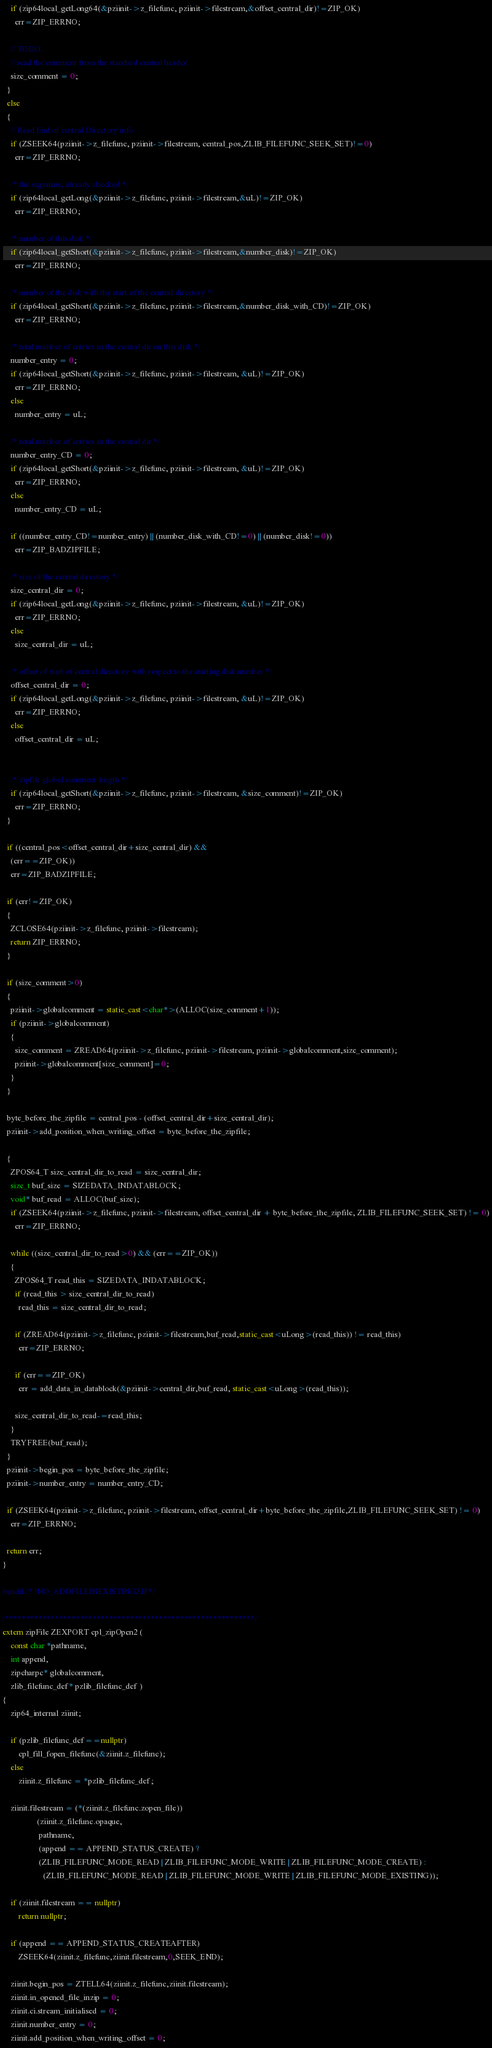Convert code to text. <code><loc_0><loc_0><loc_500><loc_500><_C++_>    if (zip64local_getLong64(&pziinit->z_filefunc, pziinit->filestream,&offset_central_dir)!=ZIP_OK)
      err=ZIP_ERRNO;

    // TODO..
    // read the comment from the standard central header.
    size_comment = 0;
  }
  else
  {
    // Read End of central Directory info
    if (ZSEEK64(pziinit->z_filefunc, pziinit->filestream, central_pos,ZLIB_FILEFUNC_SEEK_SET)!=0)
      err=ZIP_ERRNO;

    /* the signature, already checked */
    if (zip64local_getLong(&pziinit->z_filefunc, pziinit->filestream,&uL)!=ZIP_OK)
      err=ZIP_ERRNO;

    /* number of this disk */
    if (zip64local_getShort(&pziinit->z_filefunc, pziinit->filestream,&number_disk)!=ZIP_OK)
      err=ZIP_ERRNO;

    /* number of the disk with the start of the central directory */
    if (zip64local_getShort(&pziinit->z_filefunc, pziinit->filestream,&number_disk_with_CD)!=ZIP_OK)
      err=ZIP_ERRNO;

    /* total number of entries in the central dir on this disk */
    number_entry = 0;
    if (zip64local_getShort(&pziinit->z_filefunc, pziinit->filestream, &uL)!=ZIP_OK)
      err=ZIP_ERRNO;
    else
      number_entry = uL;

    /* total number of entries in the central dir */
    number_entry_CD = 0;
    if (zip64local_getShort(&pziinit->z_filefunc, pziinit->filestream, &uL)!=ZIP_OK)
      err=ZIP_ERRNO;
    else
      number_entry_CD = uL;

    if ((number_entry_CD!=number_entry) || (number_disk_with_CD!=0) || (number_disk!=0))
      err=ZIP_BADZIPFILE;

    /* size of the central directory */
    size_central_dir = 0;
    if (zip64local_getLong(&pziinit->z_filefunc, pziinit->filestream, &uL)!=ZIP_OK)
      err=ZIP_ERRNO;
    else
      size_central_dir = uL;

    /* offset of start of central directory with respect to the starting disk number */
    offset_central_dir = 0;
    if (zip64local_getLong(&pziinit->z_filefunc, pziinit->filestream, &uL)!=ZIP_OK)
      err=ZIP_ERRNO;
    else
      offset_central_dir = uL;


    /* zipfile global comment length */
    if (zip64local_getShort(&pziinit->z_filefunc, pziinit->filestream, &size_comment)!=ZIP_OK)
      err=ZIP_ERRNO;
  }

  if ((central_pos<offset_central_dir+size_central_dir) &&
    (err==ZIP_OK))
    err=ZIP_BADZIPFILE;

  if (err!=ZIP_OK)
  {
    ZCLOSE64(pziinit->z_filefunc, pziinit->filestream);
    return ZIP_ERRNO;
  }

  if (size_comment>0)
  {
    pziinit->globalcomment = static_cast<char*>(ALLOC(size_comment+1));
    if (pziinit->globalcomment)
    {
      size_comment = ZREAD64(pziinit->z_filefunc, pziinit->filestream, pziinit->globalcomment,size_comment);
      pziinit->globalcomment[size_comment]=0;
    }
  }

  byte_before_the_zipfile = central_pos - (offset_central_dir+size_central_dir);
  pziinit->add_position_when_writing_offset = byte_before_the_zipfile;

  {
    ZPOS64_T size_central_dir_to_read = size_central_dir;
    size_t buf_size = SIZEDATA_INDATABLOCK;
    void* buf_read = ALLOC(buf_size);
    if (ZSEEK64(pziinit->z_filefunc, pziinit->filestream, offset_central_dir + byte_before_the_zipfile, ZLIB_FILEFUNC_SEEK_SET) != 0)
      err=ZIP_ERRNO;

    while ((size_central_dir_to_read>0) && (err==ZIP_OK))
    {
      ZPOS64_T read_this = SIZEDATA_INDATABLOCK;
      if (read_this > size_central_dir_to_read)
        read_this = size_central_dir_to_read;

      if (ZREAD64(pziinit->z_filefunc, pziinit->filestream,buf_read,static_cast<uLong>(read_this)) != read_this)
        err=ZIP_ERRNO;

      if (err==ZIP_OK)
        err = add_data_in_datablock(&pziinit->central_dir,buf_read, static_cast<uLong>(read_this));

      size_central_dir_to_read-=read_this;
    }
    TRYFREE(buf_read);
  }
  pziinit->begin_pos = byte_before_the_zipfile;
  pziinit->number_entry = number_entry_CD;

  if (ZSEEK64(pziinit->z_filefunc, pziinit->filestream, offset_central_dir+byte_before_the_zipfile,ZLIB_FILEFUNC_SEEK_SET) != 0)
    err=ZIP_ERRNO;

  return err;
}

#endif /* !NO_ADDFILEINEXISTINGZIP*/

/************************************************************/
extern zipFile ZEXPORT cpl_zipOpen2 (
    const char *pathname,
    int append,
    zipcharpc* globalcomment,
    zlib_filefunc_def* pzlib_filefunc_def )
{
    zip64_internal ziinit;

    if (pzlib_filefunc_def==nullptr)
        cpl_fill_fopen_filefunc(&ziinit.z_filefunc);
    else
        ziinit.z_filefunc = *pzlib_filefunc_def;

    ziinit.filestream = (*(ziinit.z_filefunc.zopen_file))
                 (ziinit.z_filefunc.opaque,
                  pathname,
                  (append == APPEND_STATUS_CREATE) ?
                  (ZLIB_FILEFUNC_MODE_READ | ZLIB_FILEFUNC_MODE_WRITE | ZLIB_FILEFUNC_MODE_CREATE) :
                    (ZLIB_FILEFUNC_MODE_READ | ZLIB_FILEFUNC_MODE_WRITE | ZLIB_FILEFUNC_MODE_EXISTING));

    if (ziinit.filestream == nullptr)
        return nullptr;

    if (append == APPEND_STATUS_CREATEAFTER)
        ZSEEK64(ziinit.z_filefunc,ziinit.filestream,0,SEEK_END);

    ziinit.begin_pos = ZTELL64(ziinit.z_filefunc,ziinit.filestream);
    ziinit.in_opened_file_inzip = 0;
    ziinit.ci.stream_initialised = 0;
    ziinit.number_entry = 0;
    ziinit.add_position_when_writing_offset = 0;</code> 